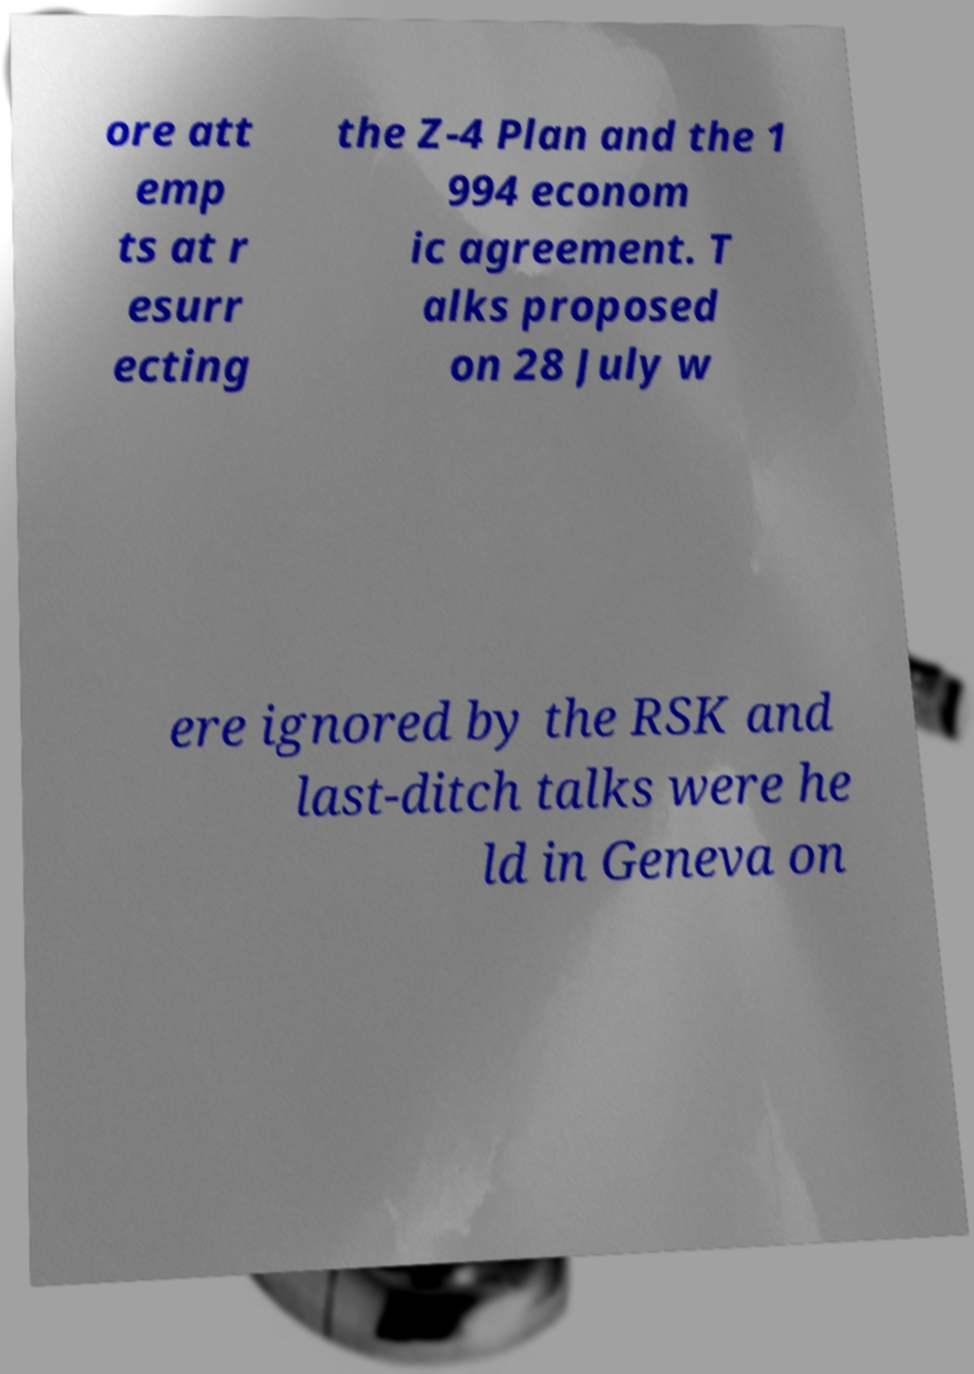Please read and relay the text visible in this image. What does it say? ore att emp ts at r esurr ecting the Z-4 Plan and the 1 994 econom ic agreement. T alks proposed on 28 July w ere ignored by the RSK and last-ditch talks were he ld in Geneva on 